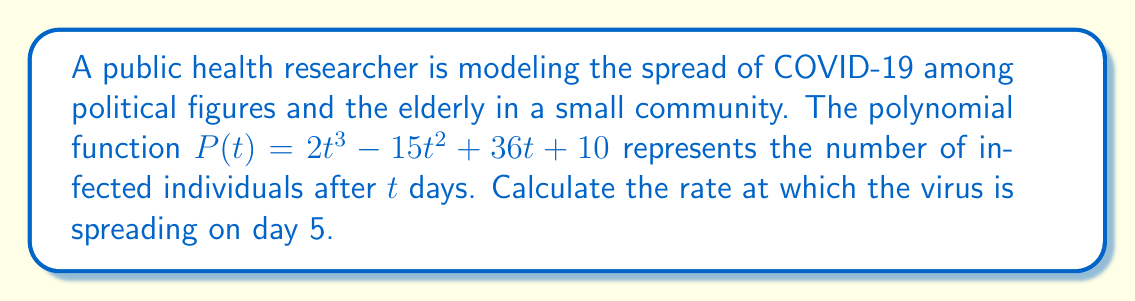Solve this math problem. To find the rate at which the virus is spreading on day 5, we need to calculate the derivative of the polynomial function $P(t)$ and evaluate it at $t=5$. This will give us the instantaneous rate of change at that point.

Step 1: Calculate the derivative of $P(t)$.
$$P(t) = 2t^3 - 15t^2 + 36t + 10$$
$$P'(t) = 6t^2 - 30t + 36$$

Step 2: Evaluate $P'(t)$ at $t=5$.
$$P'(5) = 6(5^2) - 30(5) + 36$$
$$P'(5) = 6(25) - 150 + 36$$
$$P'(5) = 150 - 150 + 36$$
$$P'(5) = 36$$

Therefore, on day 5, the virus is spreading at a rate of 36 new cases per day among political figures and the elderly in this community.
Answer: 36 new cases per day 